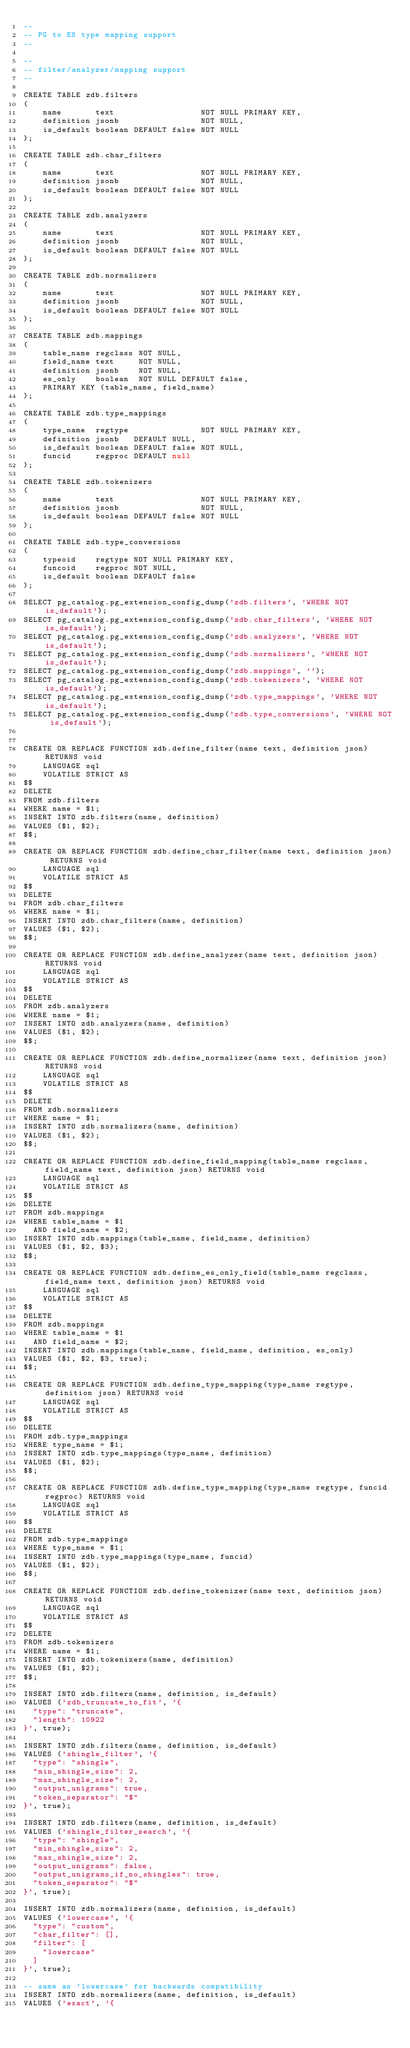<code> <loc_0><loc_0><loc_500><loc_500><_SQL_>--
-- PG to ES type mapping support
--

--
-- filter/analyzer/mapping support
--

CREATE TABLE zdb.filters
(
    name       text                  NOT NULL PRIMARY KEY,
    definition jsonb                 NOT NULL,
    is_default boolean DEFAULT false NOT NULL
);

CREATE TABLE zdb.char_filters
(
    name       text                  NOT NULL PRIMARY KEY,
    definition jsonb                 NOT NULL,
    is_default boolean DEFAULT false NOT NULL
);

CREATE TABLE zdb.analyzers
(
    name       text                  NOT NULL PRIMARY KEY,
    definition jsonb                 NOT NULL,
    is_default boolean DEFAULT false NOT NULL
);

CREATE TABLE zdb.normalizers
(
    name       text                  NOT NULL PRIMARY KEY,
    definition jsonb                 NOT NULL,
    is_default boolean DEFAULT false NOT NULL
);

CREATE TABLE zdb.mappings
(
    table_name regclass NOT NULL,
    field_name text     NOT NULL,
    definition jsonb    NOT NULL,
    es_only    boolean  NOT NULL DEFAULT false,
    PRIMARY KEY (table_name, field_name)
);

CREATE TABLE zdb.type_mappings
(
    type_name  regtype               NOT NULL PRIMARY KEY,
    definition jsonb   DEFAULT NULL,
    is_default boolean DEFAULT false NOT NULL,
    funcid     regproc DEFAULT null
);

CREATE TABLE zdb.tokenizers
(
    name       text                  NOT NULL PRIMARY KEY,
    definition jsonb                 NOT NULL,
    is_default boolean DEFAULT false NOT NULL
);

CREATE TABLE zdb.type_conversions
(
    typeoid    regtype NOT NULL PRIMARY KEY,
    funcoid    regproc NOT NULL,
    is_default boolean DEFAULT false
);

SELECT pg_catalog.pg_extension_config_dump('zdb.filters', 'WHERE NOT is_default');
SELECT pg_catalog.pg_extension_config_dump('zdb.char_filters', 'WHERE NOT is_default');
SELECT pg_catalog.pg_extension_config_dump('zdb.analyzers', 'WHERE NOT is_default');
SELECT pg_catalog.pg_extension_config_dump('zdb.normalizers', 'WHERE NOT is_default');
SELECT pg_catalog.pg_extension_config_dump('zdb.mappings', '');
SELECT pg_catalog.pg_extension_config_dump('zdb.tokenizers', 'WHERE NOT is_default');
SELECT pg_catalog.pg_extension_config_dump('zdb.type_mappings', 'WHERE NOT is_default');
SELECT pg_catalog.pg_extension_config_dump('zdb.type_conversions', 'WHERE NOT is_default');


CREATE OR REPLACE FUNCTION zdb.define_filter(name text, definition json) RETURNS void
    LANGUAGE sql
    VOLATILE STRICT AS
$$
DELETE
FROM zdb.filters
WHERE name = $1;
INSERT INTO zdb.filters(name, definition)
VALUES ($1, $2);
$$;

CREATE OR REPLACE FUNCTION zdb.define_char_filter(name text, definition json) RETURNS void
    LANGUAGE sql
    VOLATILE STRICT AS
$$
DELETE
FROM zdb.char_filters
WHERE name = $1;
INSERT INTO zdb.char_filters(name, definition)
VALUES ($1, $2);
$$;

CREATE OR REPLACE FUNCTION zdb.define_analyzer(name text, definition json) RETURNS void
    LANGUAGE sql
    VOLATILE STRICT AS
$$
DELETE
FROM zdb.analyzers
WHERE name = $1;
INSERT INTO zdb.analyzers(name, definition)
VALUES ($1, $2);
$$;

CREATE OR REPLACE FUNCTION zdb.define_normalizer(name text, definition json) RETURNS void
    LANGUAGE sql
    VOLATILE STRICT AS
$$
DELETE
FROM zdb.normalizers
WHERE name = $1;
INSERT INTO zdb.normalizers(name, definition)
VALUES ($1, $2);
$$;

CREATE OR REPLACE FUNCTION zdb.define_field_mapping(table_name regclass, field_name text, definition json) RETURNS void
    LANGUAGE sql
    VOLATILE STRICT AS
$$
DELETE
FROM zdb.mappings
WHERE table_name = $1
  AND field_name = $2;
INSERT INTO zdb.mappings(table_name, field_name, definition)
VALUES ($1, $2, $3);
$$;

CREATE OR REPLACE FUNCTION zdb.define_es_only_field(table_name regclass, field_name text, definition json) RETURNS void
    LANGUAGE sql
    VOLATILE STRICT AS
$$
DELETE
FROM zdb.mappings
WHERE table_name = $1
  AND field_name = $2;
INSERT INTO zdb.mappings(table_name, field_name, definition, es_only)
VALUES ($1, $2, $3, true);
$$;

CREATE OR REPLACE FUNCTION zdb.define_type_mapping(type_name regtype, definition json) RETURNS void
    LANGUAGE sql
    VOLATILE STRICT AS
$$
DELETE
FROM zdb.type_mappings
WHERE type_name = $1;
INSERT INTO zdb.type_mappings(type_name, definition)
VALUES ($1, $2);
$$;

CREATE OR REPLACE FUNCTION zdb.define_type_mapping(type_name regtype, funcid regproc) RETURNS void
    LANGUAGE sql
    VOLATILE STRICT AS
$$
DELETE
FROM zdb.type_mappings
WHERE type_name = $1;
INSERT INTO zdb.type_mappings(type_name, funcid)
VALUES ($1, $2);
$$;

CREATE OR REPLACE FUNCTION zdb.define_tokenizer(name text, definition json) RETURNS void
    LANGUAGE sql
    VOLATILE STRICT AS
$$
DELETE
FROM zdb.tokenizers
WHERE name = $1;
INSERT INTO zdb.tokenizers(name, definition)
VALUES ($1, $2);
$$;

INSERT INTO zdb.filters(name, definition, is_default)
VALUES ('zdb_truncate_to_fit', '{
  "type": "truncate",
  "length": 10922
}', true);

INSERT INTO zdb.filters(name, definition, is_default)
VALUES ('shingle_filter', '{
  "type": "shingle",
  "min_shingle_size": 2,
  "max_shingle_size": 2,
  "output_unigrams": true,
  "token_separator": "$"
}', true);

INSERT INTO zdb.filters(name, definition, is_default)
VALUES ('shingle_filter_search', '{
  "type": "shingle",
  "min_shingle_size": 2,
  "max_shingle_size": 2,
  "output_unigrams": false,
  "output_unigrams_if_no_shingles": true,
  "token_separator": "$"
}', true);

INSERT INTO zdb.normalizers(name, definition, is_default)
VALUES ('lowercase', '{
  "type": "custom",
  "char_filter": [],
  "filter": [
    "lowercase"
  ]
}', true);

-- same as 'lowercase' for backwards compatibility
INSERT INTO zdb.normalizers(name, definition, is_default)
VALUES ('exact', '{</code> 